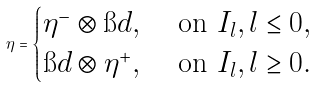Convert formula to latex. <formula><loc_0><loc_0><loc_500><loc_500>\eta = \begin{cases} \eta ^ { - } \otimes \i d , & \text { on } I _ { l } , l \leq 0 , \\ \i d \otimes \eta ^ { + } , & \text { on } I _ { l } , l \geq 0 . \end{cases}</formula> 